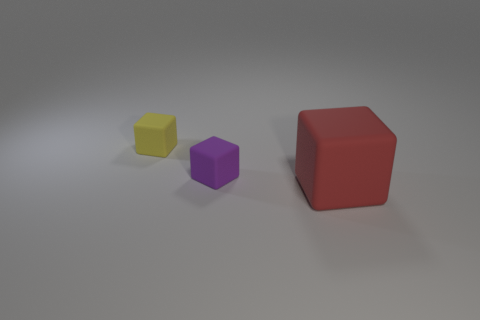Are there an equal number of small blocks to the right of the small purple block and large red rubber cubes?
Keep it short and to the point. No. What color is the other tiny object that is the same shape as the yellow object?
Offer a terse response. Purple. Does the small thing that is to the left of the purple object have the same material as the large red object?
Provide a short and direct response. Yes. How many small objects are red objects or cubes?
Ensure brevity in your answer.  2. The purple matte thing has what size?
Ensure brevity in your answer.  Small. There is a red cube; does it have the same size as the matte thing that is to the left of the tiny purple matte object?
Your answer should be very brief. No. What number of yellow objects are tiny rubber things or rubber things?
Provide a succinct answer. 1. What number of small yellow blocks are there?
Keep it short and to the point. 1. There is a red thing that is on the right side of the small yellow thing; how big is it?
Ensure brevity in your answer.  Large. Is the purple thing the same size as the yellow block?
Give a very brief answer. Yes. 